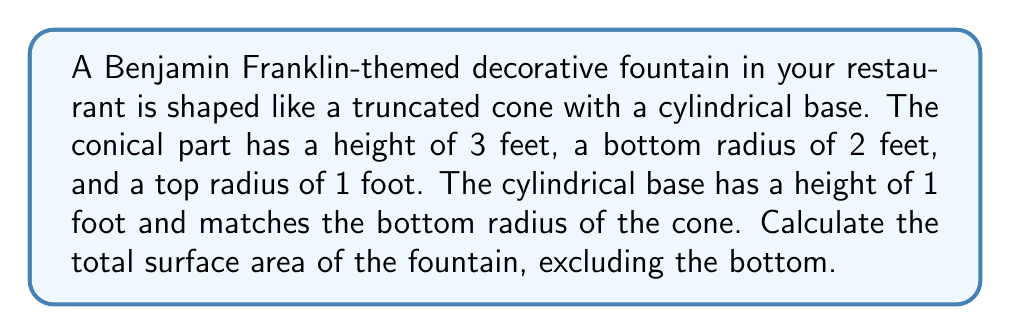Solve this math problem. Let's break this down step-by-step:

1) First, we need to calculate the surface area of the truncated cone (excluding top and bottom):
   The formula for the lateral surface area of a truncated cone is:
   $$A_c = \pi(r_1 + r_2)\sqrt{h^2 + (r_1 - r_2)^2}$$
   where $r_1$ is the bottom radius, $r_2$ is the top radius, and $h$ is the height.

   Substituting our values:
   $$A_c = \pi(2 + 1)\sqrt{3^2 + (2 - 1)^2}$$
   $$A_c = 3\pi\sqrt{9 + 1} = 3\pi\sqrt{10}$$

2) Next, we calculate the area of the top circular surface of the truncated cone:
   $$A_t = \pi r_2^2 = \pi(1^2) = \pi$$

3) Now, we calculate the lateral surface area of the cylindrical base:
   $$A_b = 2\pi rh = 2\pi(2)(1) = 4\pi$$

4) The total surface area is the sum of these three parts:
   $$A_{total} = A_c + A_t + A_b$$
   $$A_{total} = 3\pi\sqrt{10} + \pi + 4\pi$$
   $$A_{total} = \pi(3\sqrt{10} + 5)$$

5) To get a numerical value, we can approximate $\pi$ to 3.14159 and $\sqrt{10}$ to 3.16228:
   $$A_{total} \approx 3.14159(3(3.16228) + 5) \approx 45.55 \text{ sq ft}$$
Answer: $\pi(3\sqrt{10} + 5)$ sq ft, or approximately 45.55 sq ft 